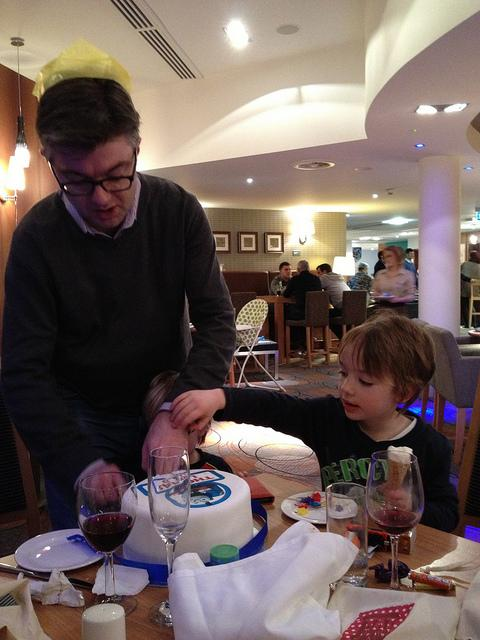Which person is likely celebrating a birthday?

Choices:
A) unknown
B) boy
C) man
D) woman boy 